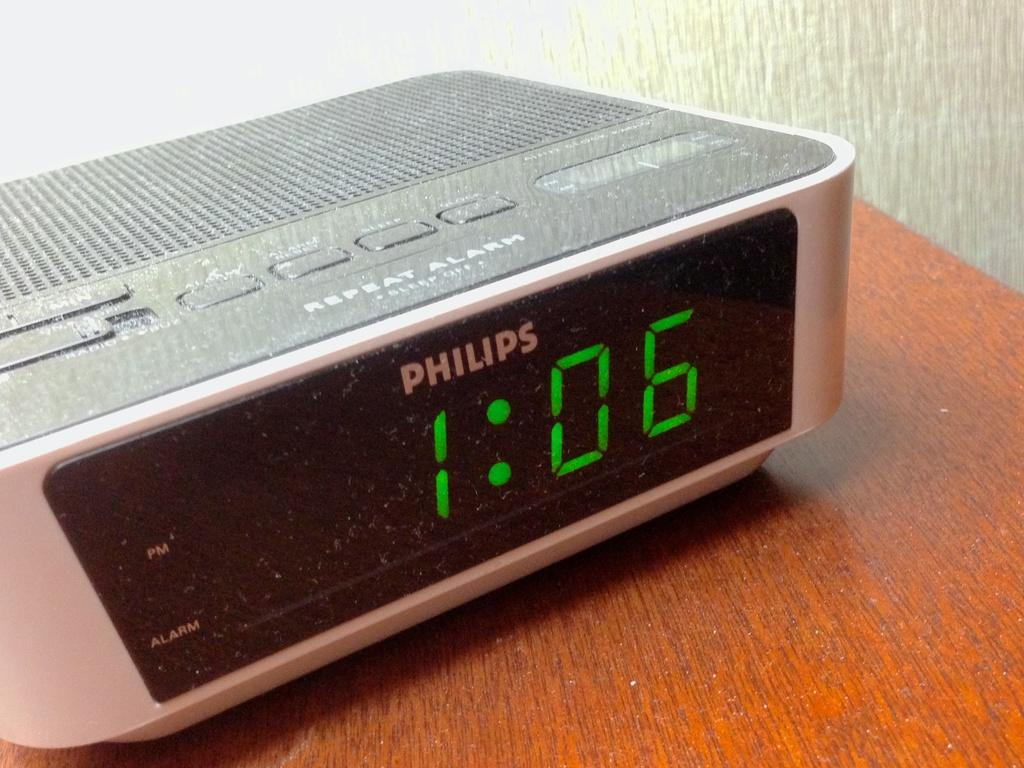<image>
Share a concise interpretation of the image provided. The Philips digital clock says the time is 1:06. 